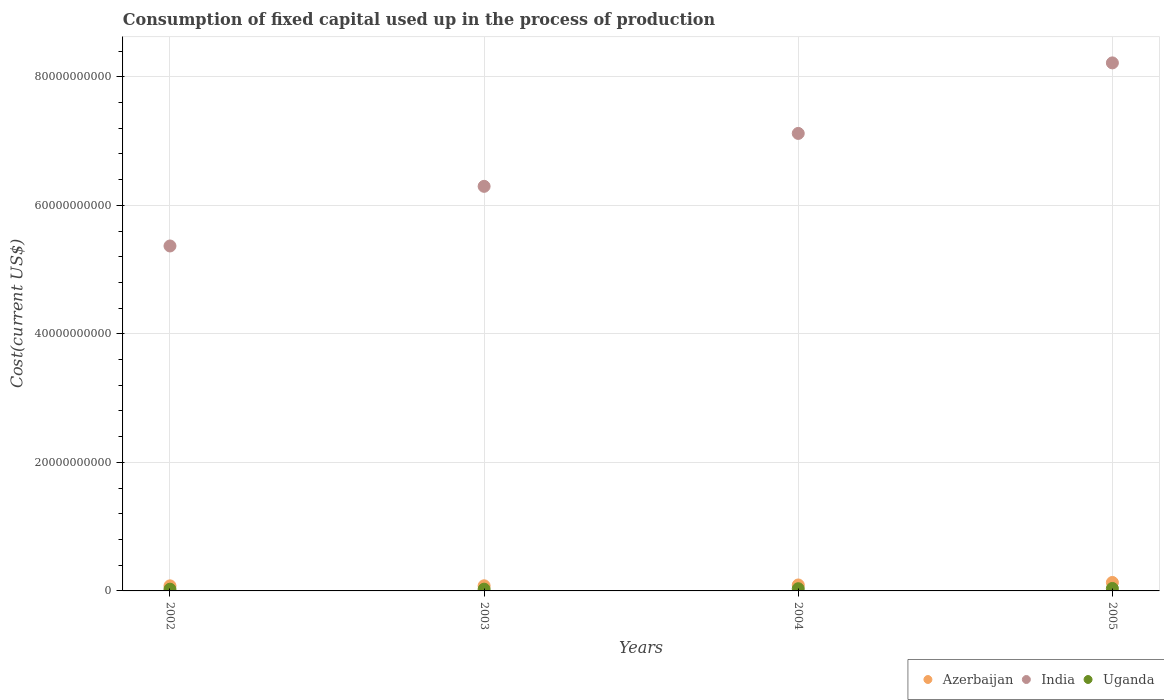Is the number of dotlines equal to the number of legend labels?
Provide a succinct answer. Yes. What is the amount consumed in the process of production in Azerbaijan in 2004?
Give a very brief answer. 9.27e+08. Across all years, what is the maximum amount consumed in the process of production in Uganda?
Make the answer very short. 3.84e+08. Across all years, what is the minimum amount consumed in the process of production in Uganda?
Ensure brevity in your answer.  2.70e+08. In which year was the amount consumed in the process of production in Azerbaijan maximum?
Your answer should be very brief. 2005. What is the total amount consumed in the process of production in India in the graph?
Offer a terse response. 2.70e+11. What is the difference between the amount consumed in the process of production in Azerbaijan in 2003 and that in 2004?
Ensure brevity in your answer.  -1.27e+08. What is the difference between the amount consumed in the process of production in India in 2004 and the amount consumed in the process of production in Uganda in 2005?
Provide a short and direct response. 7.08e+1. What is the average amount consumed in the process of production in Azerbaijan per year?
Offer a very short reply. 9.58e+08. In the year 2003, what is the difference between the amount consumed in the process of production in Azerbaijan and amount consumed in the process of production in Uganda?
Offer a terse response. 5.27e+08. In how many years, is the amount consumed in the process of production in India greater than 32000000000 US$?
Your response must be concise. 4. What is the ratio of the amount consumed in the process of production in Azerbaijan in 2004 to that in 2005?
Make the answer very short. 0.7. Is the difference between the amount consumed in the process of production in Azerbaijan in 2002 and 2003 greater than the difference between the amount consumed in the process of production in Uganda in 2002 and 2003?
Provide a succinct answer. No. What is the difference between the highest and the second highest amount consumed in the process of production in Azerbaijan?
Provide a short and direct response. 3.89e+08. What is the difference between the highest and the lowest amount consumed in the process of production in Azerbaijan?
Your answer should be very brief. 5.26e+08. In how many years, is the amount consumed in the process of production in Uganda greater than the average amount consumed in the process of production in Uganda taken over all years?
Offer a very short reply. 2. Is it the case that in every year, the sum of the amount consumed in the process of production in India and amount consumed in the process of production in Azerbaijan  is greater than the amount consumed in the process of production in Uganda?
Keep it short and to the point. Yes. Is the amount consumed in the process of production in Uganda strictly less than the amount consumed in the process of production in India over the years?
Your answer should be compact. Yes. How many years are there in the graph?
Ensure brevity in your answer.  4. What is the difference between two consecutive major ticks on the Y-axis?
Provide a short and direct response. 2.00e+1. Does the graph contain grids?
Provide a short and direct response. Yes. How are the legend labels stacked?
Give a very brief answer. Horizontal. What is the title of the graph?
Your answer should be very brief. Consumption of fixed capital used up in the process of production. What is the label or title of the Y-axis?
Your answer should be compact. Cost(current US$). What is the Cost(current US$) of Azerbaijan in 2002?
Offer a very short reply. 7.90e+08. What is the Cost(current US$) in India in 2002?
Offer a terse response. 5.37e+1. What is the Cost(current US$) in Uganda in 2002?
Provide a short and direct response. 2.70e+08. What is the Cost(current US$) of Azerbaijan in 2003?
Offer a very short reply. 8.00e+08. What is the Cost(current US$) of India in 2003?
Make the answer very short. 6.30e+1. What is the Cost(current US$) in Uganda in 2003?
Provide a succinct answer. 2.73e+08. What is the Cost(current US$) in Azerbaijan in 2004?
Your response must be concise. 9.27e+08. What is the Cost(current US$) in India in 2004?
Offer a terse response. 7.12e+1. What is the Cost(current US$) in Uganda in 2004?
Provide a short and direct response. 3.42e+08. What is the Cost(current US$) of Azerbaijan in 2005?
Your answer should be very brief. 1.32e+09. What is the Cost(current US$) in India in 2005?
Offer a very short reply. 8.22e+1. What is the Cost(current US$) in Uganda in 2005?
Your response must be concise. 3.84e+08. Across all years, what is the maximum Cost(current US$) of Azerbaijan?
Make the answer very short. 1.32e+09. Across all years, what is the maximum Cost(current US$) in India?
Your response must be concise. 8.22e+1. Across all years, what is the maximum Cost(current US$) in Uganda?
Provide a short and direct response. 3.84e+08. Across all years, what is the minimum Cost(current US$) in Azerbaijan?
Offer a terse response. 7.90e+08. Across all years, what is the minimum Cost(current US$) in India?
Your answer should be compact. 5.37e+1. Across all years, what is the minimum Cost(current US$) in Uganda?
Ensure brevity in your answer.  2.70e+08. What is the total Cost(current US$) of Azerbaijan in the graph?
Offer a very short reply. 3.83e+09. What is the total Cost(current US$) in India in the graph?
Provide a short and direct response. 2.70e+11. What is the total Cost(current US$) in Uganda in the graph?
Your answer should be very brief. 1.27e+09. What is the difference between the Cost(current US$) in Azerbaijan in 2002 and that in 2003?
Provide a succinct answer. -1.00e+07. What is the difference between the Cost(current US$) in India in 2002 and that in 2003?
Provide a succinct answer. -9.28e+09. What is the difference between the Cost(current US$) of Uganda in 2002 and that in 2003?
Ensure brevity in your answer.  -2.72e+06. What is the difference between the Cost(current US$) in Azerbaijan in 2002 and that in 2004?
Offer a terse response. -1.37e+08. What is the difference between the Cost(current US$) in India in 2002 and that in 2004?
Offer a very short reply. -1.75e+1. What is the difference between the Cost(current US$) of Uganda in 2002 and that in 2004?
Provide a succinct answer. -7.20e+07. What is the difference between the Cost(current US$) in Azerbaijan in 2002 and that in 2005?
Ensure brevity in your answer.  -5.26e+08. What is the difference between the Cost(current US$) of India in 2002 and that in 2005?
Offer a very short reply. -2.85e+1. What is the difference between the Cost(current US$) in Uganda in 2002 and that in 2005?
Ensure brevity in your answer.  -1.14e+08. What is the difference between the Cost(current US$) in Azerbaijan in 2003 and that in 2004?
Offer a terse response. -1.27e+08. What is the difference between the Cost(current US$) of India in 2003 and that in 2004?
Ensure brevity in your answer.  -8.24e+09. What is the difference between the Cost(current US$) of Uganda in 2003 and that in 2004?
Offer a terse response. -6.93e+07. What is the difference between the Cost(current US$) in Azerbaijan in 2003 and that in 2005?
Make the answer very short. -5.16e+08. What is the difference between the Cost(current US$) in India in 2003 and that in 2005?
Keep it short and to the point. -1.92e+1. What is the difference between the Cost(current US$) in Uganda in 2003 and that in 2005?
Offer a terse response. -1.11e+08. What is the difference between the Cost(current US$) of Azerbaijan in 2004 and that in 2005?
Offer a terse response. -3.89e+08. What is the difference between the Cost(current US$) of India in 2004 and that in 2005?
Provide a succinct answer. -1.10e+1. What is the difference between the Cost(current US$) of Uganda in 2004 and that in 2005?
Offer a terse response. -4.17e+07. What is the difference between the Cost(current US$) of Azerbaijan in 2002 and the Cost(current US$) of India in 2003?
Your response must be concise. -6.22e+1. What is the difference between the Cost(current US$) of Azerbaijan in 2002 and the Cost(current US$) of Uganda in 2003?
Ensure brevity in your answer.  5.17e+08. What is the difference between the Cost(current US$) in India in 2002 and the Cost(current US$) in Uganda in 2003?
Make the answer very short. 5.34e+1. What is the difference between the Cost(current US$) of Azerbaijan in 2002 and the Cost(current US$) of India in 2004?
Provide a short and direct response. -7.04e+1. What is the difference between the Cost(current US$) in Azerbaijan in 2002 and the Cost(current US$) in Uganda in 2004?
Offer a very short reply. 4.48e+08. What is the difference between the Cost(current US$) of India in 2002 and the Cost(current US$) of Uganda in 2004?
Provide a succinct answer. 5.33e+1. What is the difference between the Cost(current US$) of Azerbaijan in 2002 and the Cost(current US$) of India in 2005?
Provide a succinct answer. -8.14e+1. What is the difference between the Cost(current US$) in Azerbaijan in 2002 and the Cost(current US$) in Uganda in 2005?
Offer a terse response. 4.06e+08. What is the difference between the Cost(current US$) in India in 2002 and the Cost(current US$) in Uganda in 2005?
Ensure brevity in your answer.  5.33e+1. What is the difference between the Cost(current US$) of Azerbaijan in 2003 and the Cost(current US$) of India in 2004?
Give a very brief answer. -7.04e+1. What is the difference between the Cost(current US$) in Azerbaijan in 2003 and the Cost(current US$) in Uganda in 2004?
Provide a short and direct response. 4.58e+08. What is the difference between the Cost(current US$) of India in 2003 and the Cost(current US$) of Uganda in 2004?
Your answer should be compact. 6.26e+1. What is the difference between the Cost(current US$) of Azerbaijan in 2003 and the Cost(current US$) of India in 2005?
Offer a very short reply. -8.14e+1. What is the difference between the Cost(current US$) in Azerbaijan in 2003 and the Cost(current US$) in Uganda in 2005?
Your answer should be compact. 4.16e+08. What is the difference between the Cost(current US$) of India in 2003 and the Cost(current US$) of Uganda in 2005?
Offer a terse response. 6.26e+1. What is the difference between the Cost(current US$) of Azerbaijan in 2004 and the Cost(current US$) of India in 2005?
Provide a succinct answer. -8.12e+1. What is the difference between the Cost(current US$) of Azerbaijan in 2004 and the Cost(current US$) of Uganda in 2005?
Offer a very short reply. 5.43e+08. What is the difference between the Cost(current US$) in India in 2004 and the Cost(current US$) in Uganda in 2005?
Ensure brevity in your answer.  7.08e+1. What is the average Cost(current US$) of Azerbaijan per year?
Make the answer very short. 9.58e+08. What is the average Cost(current US$) in India per year?
Provide a succinct answer. 6.75e+1. What is the average Cost(current US$) of Uganda per year?
Your answer should be very brief. 3.17e+08. In the year 2002, what is the difference between the Cost(current US$) in Azerbaijan and Cost(current US$) in India?
Provide a short and direct response. -5.29e+1. In the year 2002, what is the difference between the Cost(current US$) in Azerbaijan and Cost(current US$) in Uganda?
Your response must be concise. 5.20e+08. In the year 2002, what is the difference between the Cost(current US$) of India and Cost(current US$) of Uganda?
Your response must be concise. 5.34e+1. In the year 2003, what is the difference between the Cost(current US$) of Azerbaijan and Cost(current US$) of India?
Make the answer very short. -6.22e+1. In the year 2003, what is the difference between the Cost(current US$) in Azerbaijan and Cost(current US$) in Uganda?
Your answer should be compact. 5.27e+08. In the year 2003, what is the difference between the Cost(current US$) of India and Cost(current US$) of Uganda?
Keep it short and to the point. 6.27e+1. In the year 2004, what is the difference between the Cost(current US$) in Azerbaijan and Cost(current US$) in India?
Keep it short and to the point. -7.03e+1. In the year 2004, what is the difference between the Cost(current US$) of Azerbaijan and Cost(current US$) of Uganda?
Your answer should be compact. 5.85e+08. In the year 2004, what is the difference between the Cost(current US$) in India and Cost(current US$) in Uganda?
Provide a short and direct response. 7.09e+1. In the year 2005, what is the difference between the Cost(current US$) of Azerbaijan and Cost(current US$) of India?
Offer a terse response. -8.09e+1. In the year 2005, what is the difference between the Cost(current US$) in Azerbaijan and Cost(current US$) in Uganda?
Provide a succinct answer. 9.32e+08. In the year 2005, what is the difference between the Cost(current US$) of India and Cost(current US$) of Uganda?
Provide a short and direct response. 8.18e+1. What is the ratio of the Cost(current US$) of Azerbaijan in 2002 to that in 2003?
Ensure brevity in your answer.  0.99. What is the ratio of the Cost(current US$) of India in 2002 to that in 2003?
Make the answer very short. 0.85. What is the ratio of the Cost(current US$) of Uganda in 2002 to that in 2003?
Ensure brevity in your answer.  0.99. What is the ratio of the Cost(current US$) in Azerbaijan in 2002 to that in 2004?
Ensure brevity in your answer.  0.85. What is the ratio of the Cost(current US$) in India in 2002 to that in 2004?
Your answer should be compact. 0.75. What is the ratio of the Cost(current US$) of Uganda in 2002 to that in 2004?
Make the answer very short. 0.79. What is the ratio of the Cost(current US$) in Azerbaijan in 2002 to that in 2005?
Your answer should be very brief. 0.6. What is the ratio of the Cost(current US$) of India in 2002 to that in 2005?
Your response must be concise. 0.65. What is the ratio of the Cost(current US$) in Uganda in 2002 to that in 2005?
Offer a terse response. 0.7. What is the ratio of the Cost(current US$) in Azerbaijan in 2003 to that in 2004?
Your answer should be very brief. 0.86. What is the ratio of the Cost(current US$) of India in 2003 to that in 2004?
Keep it short and to the point. 0.88. What is the ratio of the Cost(current US$) in Uganda in 2003 to that in 2004?
Keep it short and to the point. 0.8. What is the ratio of the Cost(current US$) of Azerbaijan in 2003 to that in 2005?
Provide a short and direct response. 0.61. What is the ratio of the Cost(current US$) in India in 2003 to that in 2005?
Offer a very short reply. 0.77. What is the ratio of the Cost(current US$) in Uganda in 2003 to that in 2005?
Keep it short and to the point. 0.71. What is the ratio of the Cost(current US$) of Azerbaijan in 2004 to that in 2005?
Make the answer very short. 0.7. What is the ratio of the Cost(current US$) of India in 2004 to that in 2005?
Ensure brevity in your answer.  0.87. What is the ratio of the Cost(current US$) of Uganda in 2004 to that in 2005?
Your answer should be compact. 0.89. What is the difference between the highest and the second highest Cost(current US$) in Azerbaijan?
Offer a terse response. 3.89e+08. What is the difference between the highest and the second highest Cost(current US$) in India?
Your response must be concise. 1.10e+1. What is the difference between the highest and the second highest Cost(current US$) of Uganda?
Your answer should be very brief. 4.17e+07. What is the difference between the highest and the lowest Cost(current US$) in Azerbaijan?
Your answer should be compact. 5.26e+08. What is the difference between the highest and the lowest Cost(current US$) of India?
Give a very brief answer. 2.85e+1. What is the difference between the highest and the lowest Cost(current US$) of Uganda?
Give a very brief answer. 1.14e+08. 